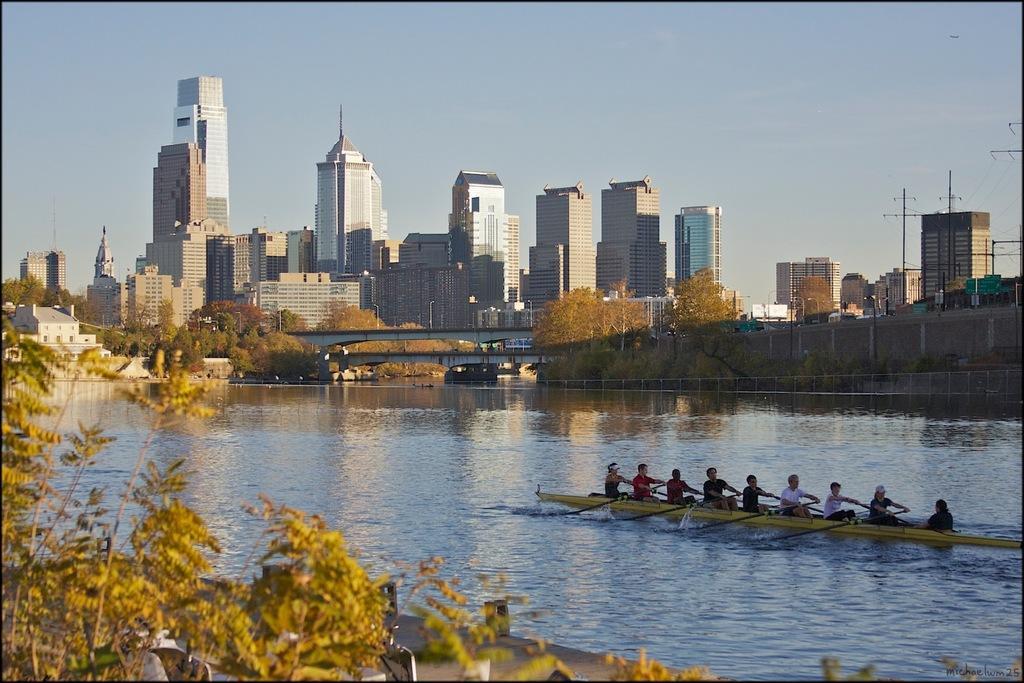Could you give a brief overview of what you see in this image? In this picture I can see few people are boating on the water, around I can see some trees, buildings, fencing. 